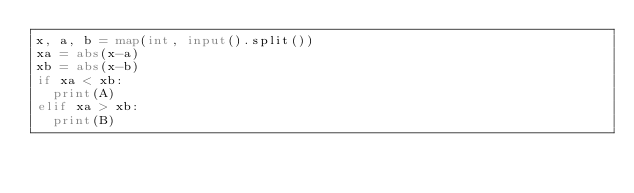<code> <loc_0><loc_0><loc_500><loc_500><_Python_>x, a, b = map(int, input().split())
xa = abs(x-a)
xb = abs(x-b)
if xa < xb:
  print(A)
elif xa > xb:
  print(B)</code> 